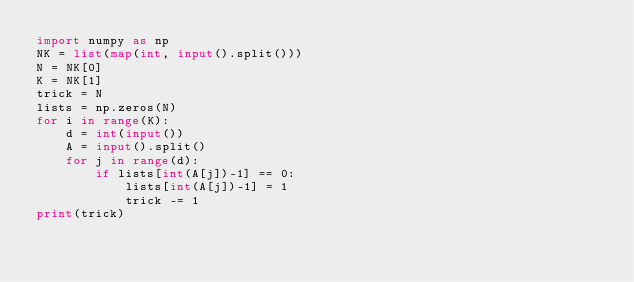Convert code to text. <code><loc_0><loc_0><loc_500><loc_500><_Python_>import numpy as np
NK = list(map(int, input().split()))
N = NK[0]
K = NK[1]
trick = N
lists = np.zeros(N)
for i in range(K):
    d = int(input())
    A = input().split()
    for j in range(d):
        if lists[int(A[j])-1] == 0:
            lists[int(A[j])-1] = 1
            trick -= 1
print(trick)</code> 